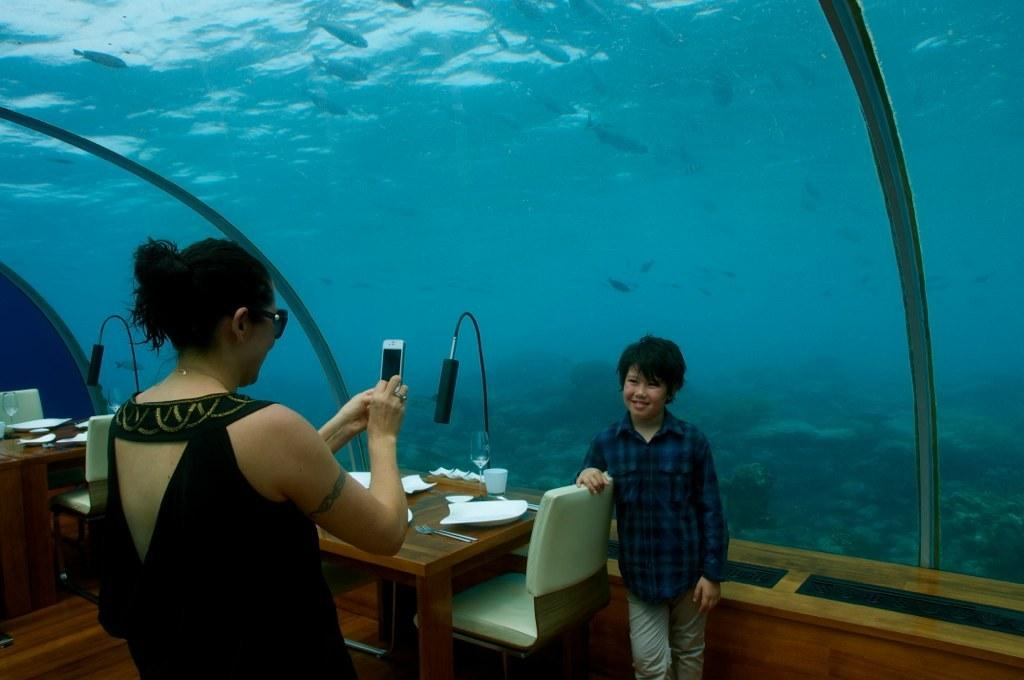Who is present in the image? There is a man and a woman in the image. What is the man doing in the image? The man is standing by holding a chair. What can be seen on the left side of the image? There is water and fishes on the left side of the image. What type of spoon is the beggar using to eat in the image? There is no beggar or spoon present in the image. 